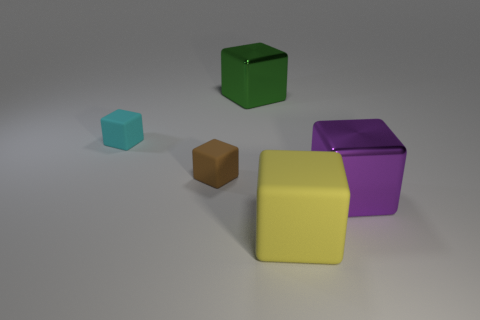Add 3 green metal objects. How many objects exist? 8 Subtract all tiny brown cubes. How many cubes are left? 4 Add 4 large matte cubes. How many large matte cubes are left? 5 Add 1 green shiny cylinders. How many green shiny cylinders exist? 1 Subtract all cyan blocks. How many blocks are left? 4 Subtract 0 gray spheres. How many objects are left? 5 Subtract 4 blocks. How many blocks are left? 1 Subtract all red cubes. Subtract all blue spheres. How many cubes are left? 5 Subtract all yellow spheres. How many purple blocks are left? 1 Subtract all cyan matte things. Subtract all tiny cyan matte cubes. How many objects are left? 3 